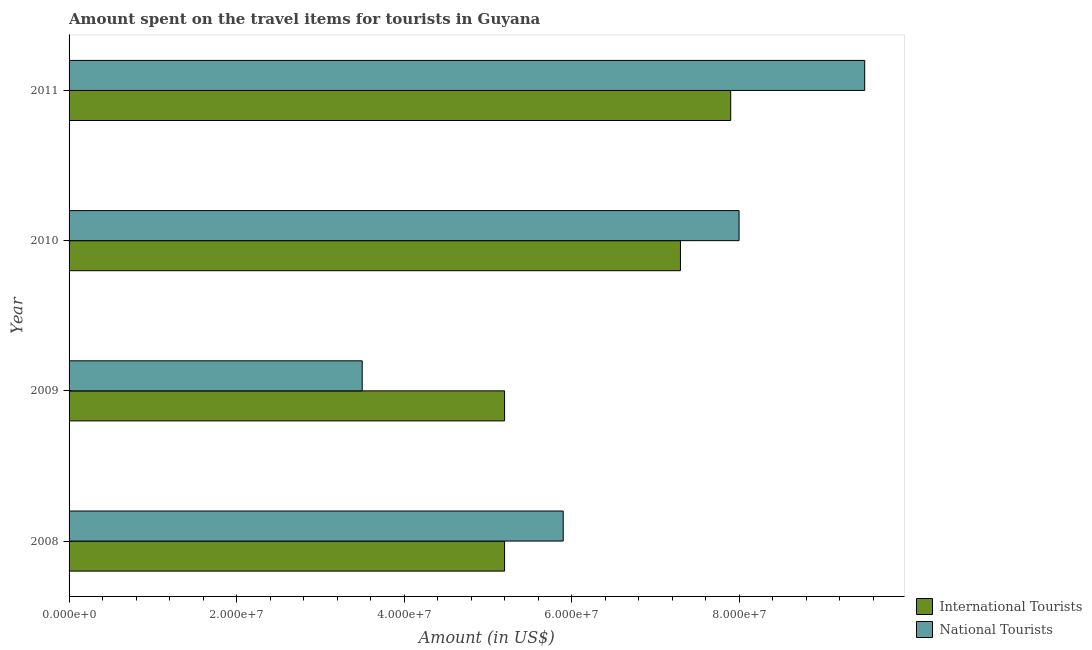How many different coloured bars are there?
Your answer should be compact. 2. Are the number of bars on each tick of the Y-axis equal?
Offer a very short reply. Yes. How many bars are there on the 4th tick from the bottom?
Your response must be concise. 2. What is the amount spent on travel items of national tourists in 2009?
Keep it short and to the point. 3.50e+07. Across all years, what is the maximum amount spent on travel items of international tourists?
Make the answer very short. 7.90e+07. Across all years, what is the minimum amount spent on travel items of international tourists?
Provide a short and direct response. 5.20e+07. In which year was the amount spent on travel items of national tourists maximum?
Give a very brief answer. 2011. What is the total amount spent on travel items of national tourists in the graph?
Offer a terse response. 2.69e+08. What is the difference between the amount spent on travel items of national tourists in 2009 and that in 2011?
Offer a very short reply. -6.00e+07. What is the difference between the amount spent on travel items of national tourists in 2008 and the amount spent on travel items of international tourists in 2010?
Keep it short and to the point. -1.40e+07. What is the average amount spent on travel items of national tourists per year?
Your answer should be very brief. 6.72e+07. In the year 2010, what is the difference between the amount spent on travel items of international tourists and amount spent on travel items of national tourists?
Ensure brevity in your answer.  -7.00e+06. What is the ratio of the amount spent on travel items of national tourists in 2008 to that in 2011?
Provide a succinct answer. 0.62. What is the difference between the highest and the lowest amount spent on travel items of international tourists?
Make the answer very short. 2.70e+07. In how many years, is the amount spent on travel items of national tourists greater than the average amount spent on travel items of national tourists taken over all years?
Keep it short and to the point. 2. What does the 2nd bar from the top in 2008 represents?
Your answer should be very brief. International Tourists. What does the 2nd bar from the bottom in 2009 represents?
Offer a very short reply. National Tourists. How many bars are there?
Ensure brevity in your answer.  8. Are all the bars in the graph horizontal?
Offer a very short reply. Yes. How many years are there in the graph?
Offer a very short reply. 4. Are the values on the major ticks of X-axis written in scientific E-notation?
Offer a very short reply. Yes. Does the graph contain grids?
Offer a very short reply. No. How are the legend labels stacked?
Make the answer very short. Vertical. What is the title of the graph?
Your answer should be very brief. Amount spent on the travel items for tourists in Guyana. Does "Commercial service imports" appear as one of the legend labels in the graph?
Your response must be concise. No. What is the label or title of the Y-axis?
Make the answer very short. Year. What is the Amount (in US$) of International Tourists in 2008?
Your answer should be very brief. 5.20e+07. What is the Amount (in US$) of National Tourists in 2008?
Your answer should be very brief. 5.90e+07. What is the Amount (in US$) of International Tourists in 2009?
Your answer should be very brief. 5.20e+07. What is the Amount (in US$) in National Tourists in 2009?
Offer a terse response. 3.50e+07. What is the Amount (in US$) in International Tourists in 2010?
Provide a short and direct response. 7.30e+07. What is the Amount (in US$) in National Tourists in 2010?
Offer a very short reply. 8.00e+07. What is the Amount (in US$) in International Tourists in 2011?
Keep it short and to the point. 7.90e+07. What is the Amount (in US$) in National Tourists in 2011?
Your answer should be compact. 9.50e+07. Across all years, what is the maximum Amount (in US$) in International Tourists?
Give a very brief answer. 7.90e+07. Across all years, what is the maximum Amount (in US$) of National Tourists?
Give a very brief answer. 9.50e+07. Across all years, what is the minimum Amount (in US$) in International Tourists?
Keep it short and to the point. 5.20e+07. Across all years, what is the minimum Amount (in US$) in National Tourists?
Offer a terse response. 3.50e+07. What is the total Amount (in US$) of International Tourists in the graph?
Offer a very short reply. 2.56e+08. What is the total Amount (in US$) in National Tourists in the graph?
Offer a terse response. 2.69e+08. What is the difference between the Amount (in US$) in International Tourists in 2008 and that in 2009?
Provide a succinct answer. 0. What is the difference between the Amount (in US$) in National Tourists in 2008 and that in 2009?
Provide a short and direct response. 2.40e+07. What is the difference between the Amount (in US$) in International Tourists in 2008 and that in 2010?
Your answer should be compact. -2.10e+07. What is the difference between the Amount (in US$) in National Tourists in 2008 and that in 2010?
Offer a very short reply. -2.10e+07. What is the difference between the Amount (in US$) in International Tourists in 2008 and that in 2011?
Your response must be concise. -2.70e+07. What is the difference between the Amount (in US$) of National Tourists in 2008 and that in 2011?
Make the answer very short. -3.60e+07. What is the difference between the Amount (in US$) in International Tourists in 2009 and that in 2010?
Ensure brevity in your answer.  -2.10e+07. What is the difference between the Amount (in US$) in National Tourists in 2009 and that in 2010?
Provide a short and direct response. -4.50e+07. What is the difference between the Amount (in US$) in International Tourists in 2009 and that in 2011?
Keep it short and to the point. -2.70e+07. What is the difference between the Amount (in US$) of National Tourists in 2009 and that in 2011?
Make the answer very short. -6.00e+07. What is the difference between the Amount (in US$) in International Tourists in 2010 and that in 2011?
Your answer should be compact. -6.00e+06. What is the difference between the Amount (in US$) in National Tourists in 2010 and that in 2011?
Give a very brief answer. -1.50e+07. What is the difference between the Amount (in US$) in International Tourists in 2008 and the Amount (in US$) in National Tourists in 2009?
Provide a short and direct response. 1.70e+07. What is the difference between the Amount (in US$) of International Tourists in 2008 and the Amount (in US$) of National Tourists in 2010?
Your answer should be compact. -2.80e+07. What is the difference between the Amount (in US$) in International Tourists in 2008 and the Amount (in US$) in National Tourists in 2011?
Offer a terse response. -4.30e+07. What is the difference between the Amount (in US$) of International Tourists in 2009 and the Amount (in US$) of National Tourists in 2010?
Provide a succinct answer. -2.80e+07. What is the difference between the Amount (in US$) in International Tourists in 2009 and the Amount (in US$) in National Tourists in 2011?
Provide a short and direct response. -4.30e+07. What is the difference between the Amount (in US$) in International Tourists in 2010 and the Amount (in US$) in National Tourists in 2011?
Provide a succinct answer. -2.20e+07. What is the average Amount (in US$) in International Tourists per year?
Give a very brief answer. 6.40e+07. What is the average Amount (in US$) of National Tourists per year?
Your answer should be very brief. 6.72e+07. In the year 2008, what is the difference between the Amount (in US$) in International Tourists and Amount (in US$) in National Tourists?
Provide a succinct answer. -7.00e+06. In the year 2009, what is the difference between the Amount (in US$) of International Tourists and Amount (in US$) of National Tourists?
Offer a very short reply. 1.70e+07. In the year 2010, what is the difference between the Amount (in US$) in International Tourists and Amount (in US$) in National Tourists?
Give a very brief answer. -7.00e+06. In the year 2011, what is the difference between the Amount (in US$) of International Tourists and Amount (in US$) of National Tourists?
Your answer should be compact. -1.60e+07. What is the ratio of the Amount (in US$) in International Tourists in 2008 to that in 2009?
Ensure brevity in your answer.  1. What is the ratio of the Amount (in US$) of National Tourists in 2008 to that in 2009?
Your answer should be compact. 1.69. What is the ratio of the Amount (in US$) of International Tourists in 2008 to that in 2010?
Your answer should be compact. 0.71. What is the ratio of the Amount (in US$) of National Tourists in 2008 to that in 2010?
Ensure brevity in your answer.  0.74. What is the ratio of the Amount (in US$) of International Tourists in 2008 to that in 2011?
Provide a short and direct response. 0.66. What is the ratio of the Amount (in US$) of National Tourists in 2008 to that in 2011?
Give a very brief answer. 0.62. What is the ratio of the Amount (in US$) of International Tourists in 2009 to that in 2010?
Offer a very short reply. 0.71. What is the ratio of the Amount (in US$) of National Tourists in 2009 to that in 2010?
Give a very brief answer. 0.44. What is the ratio of the Amount (in US$) of International Tourists in 2009 to that in 2011?
Your answer should be very brief. 0.66. What is the ratio of the Amount (in US$) in National Tourists in 2009 to that in 2011?
Provide a short and direct response. 0.37. What is the ratio of the Amount (in US$) in International Tourists in 2010 to that in 2011?
Your answer should be very brief. 0.92. What is the ratio of the Amount (in US$) of National Tourists in 2010 to that in 2011?
Keep it short and to the point. 0.84. What is the difference between the highest and the second highest Amount (in US$) of International Tourists?
Offer a very short reply. 6.00e+06. What is the difference between the highest and the second highest Amount (in US$) in National Tourists?
Offer a very short reply. 1.50e+07. What is the difference between the highest and the lowest Amount (in US$) in International Tourists?
Provide a succinct answer. 2.70e+07. What is the difference between the highest and the lowest Amount (in US$) of National Tourists?
Provide a short and direct response. 6.00e+07. 